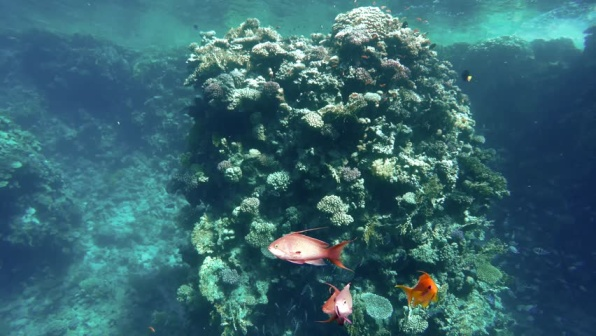Describe the interaction between the fish and the coral reef. The fish and the coral reef in the image are part of a mutually beneficial relationship. The fish, with their vibrant hues of pink, orange, and yellow, swim gracefully around the coral, feeding on the smaller organisms that live there. In turn, their movement helps to aerate the water around the coral, promoting better oxygen flow, which is essential for the health of the coral polyps. Additionally, the fish help control the population of algae and other plants that could otherwise overgrow and harm the coral. This symbiotic interaction highlights the delicate balance and interdependence within the coral reef ecosystem. How does sunlight impact the coral reef system shown in the image? Sunlight plays a crucial role in the health and productivity of the coral reef ecosystem depicted in the image. The light, penetrating through the water from the top left corner, provides the energy needed for photosynthesis, which is carried out by the symbiotic algae (zooxanthellae) living within the coral tissues. This process is vital for the production of oxygen and other nutrients that sustain the coral. Moreover, sunlight helps to regulate the water temperature, creating an environment that supports a diverse array of marine life. The gentle illumination also enhances visibility, allowing the intricate details and vivid colors of the coral and fish to be fully appreciated. If this coral reef were to be transported to an alien planet, what adaptations might it need to survive? Transporting a coral reef to an alien planet would necessitate significant adaptations to survive. Firstly, the coral and its symbiotic organisms would need to adjust to potentially different light spectra, intensity, and cycle, which may vary greatly from the sun's rays. Innovations in light-harvesting and utilization mechanisms would be essential for photosynthesis.

Secondly, the reef's flora and fauna might need to develop new physiological or biochemical adaptations to cope with potentially different water compositions, such as changes in salinity, pH, and mineral content. Additionally, the species might need to evolve new forms of resistance to unknown predators and pathogens.

Lastly, the physical structure of the coral might need to adapt to different water densities and pressures if the alien planet's oceans differ significantly from Earth's. This could involve changes in buoyancy regulation, skeletal structure, and overall morphology.

Such profound changes would highlight the incredible adaptability of life, showcasing the remarkable resilience and innovation inherent in biological systems. Imagine the coral reef as a bustling underwater city. Describe the daily life of its inhabitants. In this bustling underwater city, the coral reef transforms into a vibrant metropolis, teeming with life and activity. The corals themselves act as the towering skyscrapers, providing shelter and resources for a myriad of marine creatures. Each type of coral hosts different 'neighborhoods,' where specific species congregate and go about their daily routines.

As the sun rises and its rays penetrate the water, the day begins with schools of fish darting through the coral structures, akin to commuters navigating busy streets. The colorful fish search for food, socialize, and seek out mates in a harmonious ballet of movement. Shrimp and crabs scuttle over the coral's surface, maintaining the 'infrastructure' by cleaning algae and debris, much like caretakers and janitors ensuring the city's cleanliness.

Throughout the day, larger fish and marine creatures, such as turtles and rays, glide gracefully through the reef, visiting different 'districts' in search of sustenance. Every nook and cranny of the reef is alive with activity, from the microscopic plankton drifting in the currents to the vibrant anemones waving their tentacles in the gentle water flow.

As night falls and darkness envelops the underwater city, some inhabitants retreat into the safety of the coral structures, while nocturnal creatures emerge. The bioluminescent organisms light up the reef, creating a mesmerizing glow that illuminates the nocturnal hustle and bustle. Predators, such as eels and nocturnal fish, awaken and begin their hunt, adding an element of excitement and danger to the city's nightlife.

This dynamic, self-sustaining ecosystem thrives on the intricate web of interactions among its inhabitants, each playing a vital role in maintaining the health and balance of the coral reef city. 